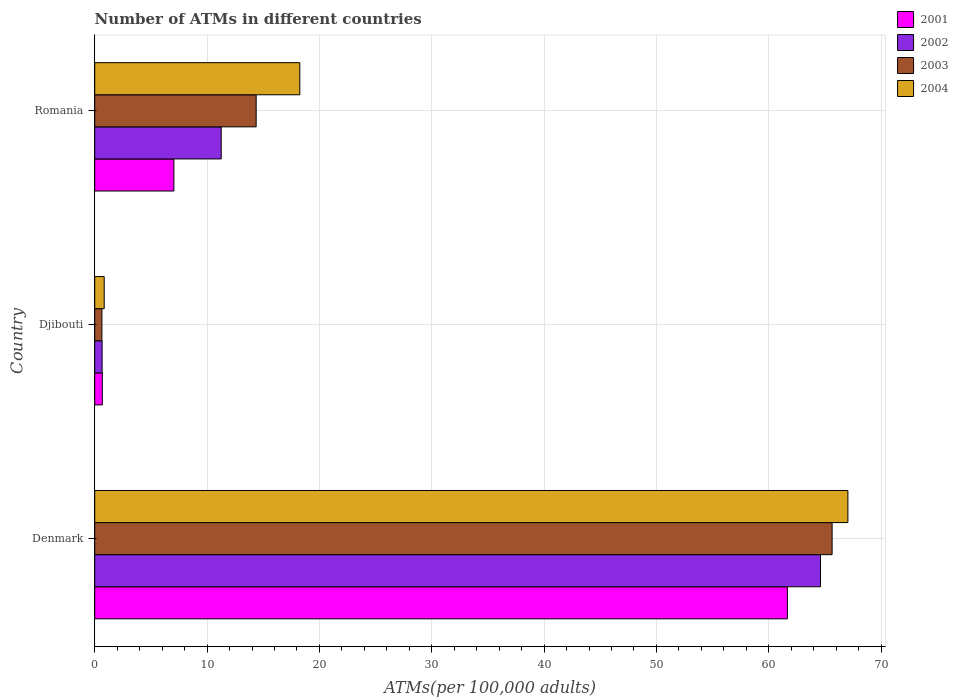How many groups of bars are there?
Your answer should be compact. 3. How many bars are there on the 3rd tick from the bottom?
Provide a short and direct response. 4. What is the label of the 3rd group of bars from the top?
Ensure brevity in your answer.  Denmark. In how many cases, is the number of bars for a given country not equal to the number of legend labels?
Your answer should be very brief. 0. What is the number of ATMs in 2002 in Djibouti?
Ensure brevity in your answer.  0.66. Across all countries, what is the maximum number of ATMs in 2003?
Keep it short and to the point. 65.64. Across all countries, what is the minimum number of ATMs in 2001?
Your response must be concise. 0.68. In which country was the number of ATMs in 2003 minimum?
Your answer should be very brief. Djibouti. What is the total number of ATMs in 2002 in the graph?
Make the answer very short. 76.52. What is the difference between the number of ATMs in 2002 in Denmark and that in Romania?
Your response must be concise. 53.35. What is the difference between the number of ATMs in 2002 in Romania and the number of ATMs in 2001 in Denmark?
Provide a short and direct response. -50.4. What is the average number of ATMs in 2001 per country?
Provide a succinct answer. 23.13. What is the difference between the number of ATMs in 2001 and number of ATMs in 2003 in Romania?
Ensure brevity in your answer.  -7.32. What is the ratio of the number of ATMs in 2002 in Denmark to that in Romania?
Provide a succinct answer. 5.74. Is the difference between the number of ATMs in 2001 in Djibouti and Romania greater than the difference between the number of ATMs in 2003 in Djibouti and Romania?
Offer a terse response. Yes. What is the difference between the highest and the second highest number of ATMs in 2002?
Your response must be concise. 53.35. What is the difference between the highest and the lowest number of ATMs in 2004?
Keep it short and to the point. 66.2. Is it the case that in every country, the sum of the number of ATMs in 2003 and number of ATMs in 2002 is greater than the sum of number of ATMs in 2004 and number of ATMs in 2001?
Keep it short and to the point. No. What does the 3rd bar from the bottom in Djibouti represents?
Keep it short and to the point. 2003. Is it the case that in every country, the sum of the number of ATMs in 2002 and number of ATMs in 2004 is greater than the number of ATMs in 2001?
Ensure brevity in your answer.  Yes. What is the difference between two consecutive major ticks on the X-axis?
Provide a short and direct response. 10. Does the graph contain any zero values?
Your response must be concise. No. How are the legend labels stacked?
Provide a succinct answer. Vertical. What is the title of the graph?
Your answer should be compact. Number of ATMs in different countries. Does "2001" appear as one of the legend labels in the graph?
Your answer should be very brief. Yes. What is the label or title of the X-axis?
Ensure brevity in your answer.  ATMs(per 100,0 adults). What is the ATMs(per 100,000 adults) of 2001 in Denmark?
Your answer should be compact. 61.66. What is the ATMs(per 100,000 adults) of 2002 in Denmark?
Your answer should be compact. 64.61. What is the ATMs(per 100,000 adults) of 2003 in Denmark?
Give a very brief answer. 65.64. What is the ATMs(per 100,000 adults) of 2004 in Denmark?
Provide a short and direct response. 67.04. What is the ATMs(per 100,000 adults) in 2001 in Djibouti?
Provide a short and direct response. 0.68. What is the ATMs(per 100,000 adults) in 2002 in Djibouti?
Provide a short and direct response. 0.66. What is the ATMs(per 100,000 adults) of 2003 in Djibouti?
Provide a short and direct response. 0.64. What is the ATMs(per 100,000 adults) of 2004 in Djibouti?
Keep it short and to the point. 0.84. What is the ATMs(per 100,000 adults) in 2001 in Romania?
Ensure brevity in your answer.  7.04. What is the ATMs(per 100,000 adults) of 2002 in Romania?
Offer a very short reply. 11.26. What is the ATMs(per 100,000 adults) of 2003 in Romania?
Ensure brevity in your answer.  14.37. What is the ATMs(per 100,000 adults) in 2004 in Romania?
Provide a succinct answer. 18.26. Across all countries, what is the maximum ATMs(per 100,000 adults) of 2001?
Your answer should be compact. 61.66. Across all countries, what is the maximum ATMs(per 100,000 adults) in 2002?
Offer a terse response. 64.61. Across all countries, what is the maximum ATMs(per 100,000 adults) in 2003?
Offer a terse response. 65.64. Across all countries, what is the maximum ATMs(per 100,000 adults) of 2004?
Make the answer very short. 67.04. Across all countries, what is the minimum ATMs(per 100,000 adults) of 2001?
Your answer should be very brief. 0.68. Across all countries, what is the minimum ATMs(per 100,000 adults) of 2002?
Your response must be concise. 0.66. Across all countries, what is the minimum ATMs(per 100,000 adults) of 2003?
Provide a short and direct response. 0.64. Across all countries, what is the minimum ATMs(per 100,000 adults) in 2004?
Offer a terse response. 0.84. What is the total ATMs(per 100,000 adults) of 2001 in the graph?
Offer a very short reply. 69.38. What is the total ATMs(per 100,000 adults) in 2002 in the graph?
Ensure brevity in your answer.  76.52. What is the total ATMs(per 100,000 adults) of 2003 in the graph?
Your response must be concise. 80.65. What is the total ATMs(per 100,000 adults) in 2004 in the graph?
Your answer should be very brief. 86.14. What is the difference between the ATMs(per 100,000 adults) in 2001 in Denmark and that in Djibouti?
Give a very brief answer. 60.98. What is the difference between the ATMs(per 100,000 adults) of 2002 in Denmark and that in Djibouti?
Give a very brief answer. 63.95. What is the difference between the ATMs(per 100,000 adults) of 2003 in Denmark and that in Djibouti?
Your answer should be compact. 65. What is the difference between the ATMs(per 100,000 adults) in 2004 in Denmark and that in Djibouti?
Give a very brief answer. 66.2. What is the difference between the ATMs(per 100,000 adults) in 2001 in Denmark and that in Romania?
Provide a succinct answer. 54.61. What is the difference between the ATMs(per 100,000 adults) in 2002 in Denmark and that in Romania?
Your answer should be very brief. 53.35. What is the difference between the ATMs(per 100,000 adults) in 2003 in Denmark and that in Romania?
Your response must be concise. 51.27. What is the difference between the ATMs(per 100,000 adults) of 2004 in Denmark and that in Romania?
Provide a succinct answer. 48.79. What is the difference between the ATMs(per 100,000 adults) in 2001 in Djibouti and that in Romania?
Your response must be concise. -6.37. What is the difference between the ATMs(per 100,000 adults) of 2002 in Djibouti and that in Romania?
Your answer should be compact. -10.6. What is the difference between the ATMs(per 100,000 adults) in 2003 in Djibouti and that in Romania?
Ensure brevity in your answer.  -13.73. What is the difference between the ATMs(per 100,000 adults) of 2004 in Djibouti and that in Romania?
Keep it short and to the point. -17.41. What is the difference between the ATMs(per 100,000 adults) of 2001 in Denmark and the ATMs(per 100,000 adults) of 2002 in Djibouti?
Offer a very short reply. 61. What is the difference between the ATMs(per 100,000 adults) of 2001 in Denmark and the ATMs(per 100,000 adults) of 2003 in Djibouti?
Make the answer very short. 61.02. What is the difference between the ATMs(per 100,000 adults) of 2001 in Denmark and the ATMs(per 100,000 adults) of 2004 in Djibouti?
Keep it short and to the point. 60.81. What is the difference between the ATMs(per 100,000 adults) of 2002 in Denmark and the ATMs(per 100,000 adults) of 2003 in Djibouti?
Your answer should be compact. 63.97. What is the difference between the ATMs(per 100,000 adults) of 2002 in Denmark and the ATMs(per 100,000 adults) of 2004 in Djibouti?
Your answer should be compact. 63.76. What is the difference between the ATMs(per 100,000 adults) in 2003 in Denmark and the ATMs(per 100,000 adults) in 2004 in Djibouti?
Offer a very short reply. 64.79. What is the difference between the ATMs(per 100,000 adults) in 2001 in Denmark and the ATMs(per 100,000 adults) in 2002 in Romania?
Offer a terse response. 50.4. What is the difference between the ATMs(per 100,000 adults) in 2001 in Denmark and the ATMs(per 100,000 adults) in 2003 in Romania?
Your answer should be very brief. 47.29. What is the difference between the ATMs(per 100,000 adults) in 2001 in Denmark and the ATMs(per 100,000 adults) in 2004 in Romania?
Provide a succinct answer. 43.4. What is the difference between the ATMs(per 100,000 adults) of 2002 in Denmark and the ATMs(per 100,000 adults) of 2003 in Romania?
Make the answer very short. 50.24. What is the difference between the ATMs(per 100,000 adults) of 2002 in Denmark and the ATMs(per 100,000 adults) of 2004 in Romania?
Offer a very short reply. 46.35. What is the difference between the ATMs(per 100,000 adults) in 2003 in Denmark and the ATMs(per 100,000 adults) in 2004 in Romania?
Your response must be concise. 47.38. What is the difference between the ATMs(per 100,000 adults) in 2001 in Djibouti and the ATMs(per 100,000 adults) in 2002 in Romania?
Offer a very short reply. -10.58. What is the difference between the ATMs(per 100,000 adults) of 2001 in Djibouti and the ATMs(per 100,000 adults) of 2003 in Romania?
Provide a short and direct response. -13.69. What is the difference between the ATMs(per 100,000 adults) in 2001 in Djibouti and the ATMs(per 100,000 adults) in 2004 in Romania?
Offer a very short reply. -17.58. What is the difference between the ATMs(per 100,000 adults) in 2002 in Djibouti and the ATMs(per 100,000 adults) in 2003 in Romania?
Offer a terse response. -13.71. What is the difference between the ATMs(per 100,000 adults) of 2002 in Djibouti and the ATMs(per 100,000 adults) of 2004 in Romania?
Offer a very short reply. -17.6. What is the difference between the ATMs(per 100,000 adults) of 2003 in Djibouti and the ATMs(per 100,000 adults) of 2004 in Romania?
Offer a very short reply. -17.62. What is the average ATMs(per 100,000 adults) in 2001 per country?
Provide a succinct answer. 23.13. What is the average ATMs(per 100,000 adults) in 2002 per country?
Your response must be concise. 25.51. What is the average ATMs(per 100,000 adults) of 2003 per country?
Give a very brief answer. 26.88. What is the average ATMs(per 100,000 adults) of 2004 per country?
Your answer should be compact. 28.71. What is the difference between the ATMs(per 100,000 adults) of 2001 and ATMs(per 100,000 adults) of 2002 in Denmark?
Make the answer very short. -2.95. What is the difference between the ATMs(per 100,000 adults) of 2001 and ATMs(per 100,000 adults) of 2003 in Denmark?
Your answer should be very brief. -3.98. What is the difference between the ATMs(per 100,000 adults) in 2001 and ATMs(per 100,000 adults) in 2004 in Denmark?
Provide a short and direct response. -5.39. What is the difference between the ATMs(per 100,000 adults) in 2002 and ATMs(per 100,000 adults) in 2003 in Denmark?
Offer a very short reply. -1.03. What is the difference between the ATMs(per 100,000 adults) of 2002 and ATMs(per 100,000 adults) of 2004 in Denmark?
Your answer should be compact. -2.44. What is the difference between the ATMs(per 100,000 adults) of 2003 and ATMs(per 100,000 adults) of 2004 in Denmark?
Ensure brevity in your answer.  -1.41. What is the difference between the ATMs(per 100,000 adults) of 2001 and ATMs(per 100,000 adults) of 2002 in Djibouti?
Keep it short and to the point. 0.02. What is the difference between the ATMs(per 100,000 adults) of 2001 and ATMs(per 100,000 adults) of 2003 in Djibouti?
Ensure brevity in your answer.  0.04. What is the difference between the ATMs(per 100,000 adults) in 2001 and ATMs(per 100,000 adults) in 2004 in Djibouti?
Your response must be concise. -0.17. What is the difference between the ATMs(per 100,000 adults) of 2002 and ATMs(per 100,000 adults) of 2003 in Djibouti?
Keep it short and to the point. 0.02. What is the difference between the ATMs(per 100,000 adults) of 2002 and ATMs(per 100,000 adults) of 2004 in Djibouti?
Offer a very short reply. -0.19. What is the difference between the ATMs(per 100,000 adults) in 2003 and ATMs(per 100,000 adults) in 2004 in Djibouti?
Make the answer very short. -0.21. What is the difference between the ATMs(per 100,000 adults) of 2001 and ATMs(per 100,000 adults) of 2002 in Romania?
Your answer should be compact. -4.21. What is the difference between the ATMs(per 100,000 adults) in 2001 and ATMs(per 100,000 adults) in 2003 in Romania?
Provide a succinct answer. -7.32. What is the difference between the ATMs(per 100,000 adults) in 2001 and ATMs(per 100,000 adults) in 2004 in Romania?
Give a very brief answer. -11.21. What is the difference between the ATMs(per 100,000 adults) in 2002 and ATMs(per 100,000 adults) in 2003 in Romania?
Provide a short and direct response. -3.11. What is the difference between the ATMs(per 100,000 adults) in 2002 and ATMs(per 100,000 adults) in 2004 in Romania?
Offer a very short reply. -7. What is the difference between the ATMs(per 100,000 adults) in 2003 and ATMs(per 100,000 adults) in 2004 in Romania?
Ensure brevity in your answer.  -3.89. What is the ratio of the ATMs(per 100,000 adults) of 2001 in Denmark to that in Djibouti?
Provide a short and direct response. 91.18. What is the ratio of the ATMs(per 100,000 adults) of 2002 in Denmark to that in Djibouti?
Offer a terse response. 98.45. What is the ratio of the ATMs(per 100,000 adults) of 2003 in Denmark to that in Djibouti?
Keep it short and to the point. 102.88. What is the ratio of the ATMs(per 100,000 adults) in 2004 in Denmark to that in Djibouti?
Provide a succinct answer. 79.46. What is the ratio of the ATMs(per 100,000 adults) in 2001 in Denmark to that in Romania?
Provide a succinct answer. 8.75. What is the ratio of the ATMs(per 100,000 adults) of 2002 in Denmark to that in Romania?
Offer a very short reply. 5.74. What is the ratio of the ATMs(per 100,000 adults) of 2003 in Denmark to that in Romania?
Ensure brevity in your answer.  4.57. What is the ratio of the ATMs(per 100,000 adults) of 2004 in Denmark to that in Romania?
Your response must be concise. 3.67. What is the ratio of the ATMs(per 100,000 adults) of 2001 in Djibouti to that in Romania?
Provide a succinct answer. 0.1. What is the ratio of the ATMs(per 100,000 adults) of 2002 in Djibouti to that in Romania?
Your response must be concise. 0.06. What is the ratio of the ATMs(per 100,000 adults) in 2003 in Djibouti to that in Romania?
Offer a terse response. 0.04. What is the ratio of the ATMs(per 100,000 adults) of 2004 in Djibouti to that in Romania?
Your answer should be very brief. 0.05. What is the difference between the highest and the second highest ATMs(per 100,000 adults) of 2001?
Give a very brief answer. 54.61. What is the difference between the highest and the second highest ATMs(per 100,000 adults) in 2002?
Your response must be concise. 53.35. What is the difference between the highest and the second highest ATMs(per 100,000 adults) of 2003?
Your answer should be very brief. 51.27. What is the difference between the highest and the second highest ATMs(per 100,000 adults) in 2004?
Keep it short and to the point. 48.79. What is the difference between the highest and the lowest ATMs(per 100,000 adults) in 2001?
Keep it short and to the point. 60.98. What is the difference between the highest and the lowest ATMs(per 100,000 adults) in 2002?
Provide a succinct answer. 63.95. What is the difference between the highest and the lowest ATMs(per 100,000 adults) in 2003?
Keep it short and to the point. 65. What is the difference between the highest and the lowest ATMs(per 100,000 adults) in 2004?
Your response must be concise. 66.2. 